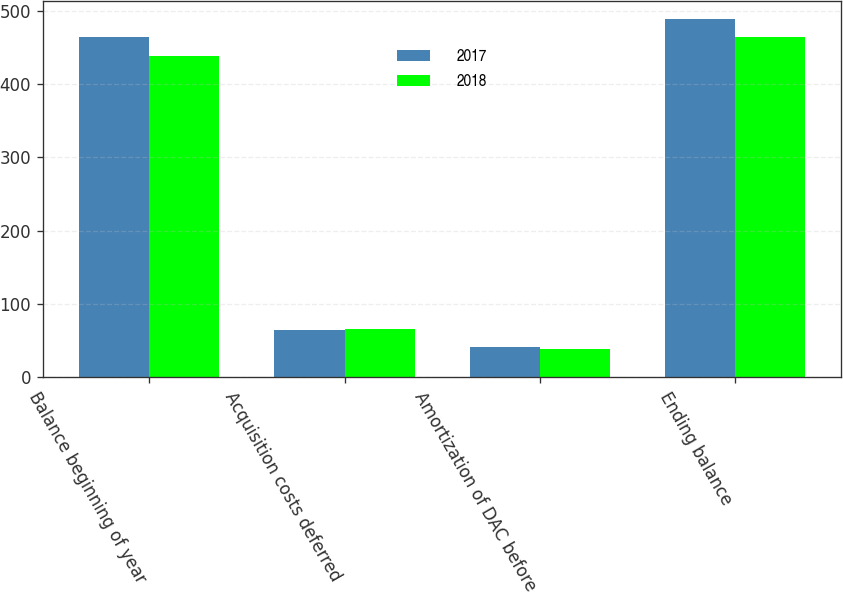Convert chart. <chart><loc_0><loc_0><loc_500><loc_500><stacked_bar_chart><ecel><fcel>Balance beginning of year<fcel>Acquisition costs deferred<fcel>Amortization of DAC before<fcel>Ending balance<nl><fcel>2017<fcel>465<fcel>65<fcel>41<fcel>489<nl><fcel>2018<fcel>438<fcel>66<fcel>39<fcel>465<nl></chart> 